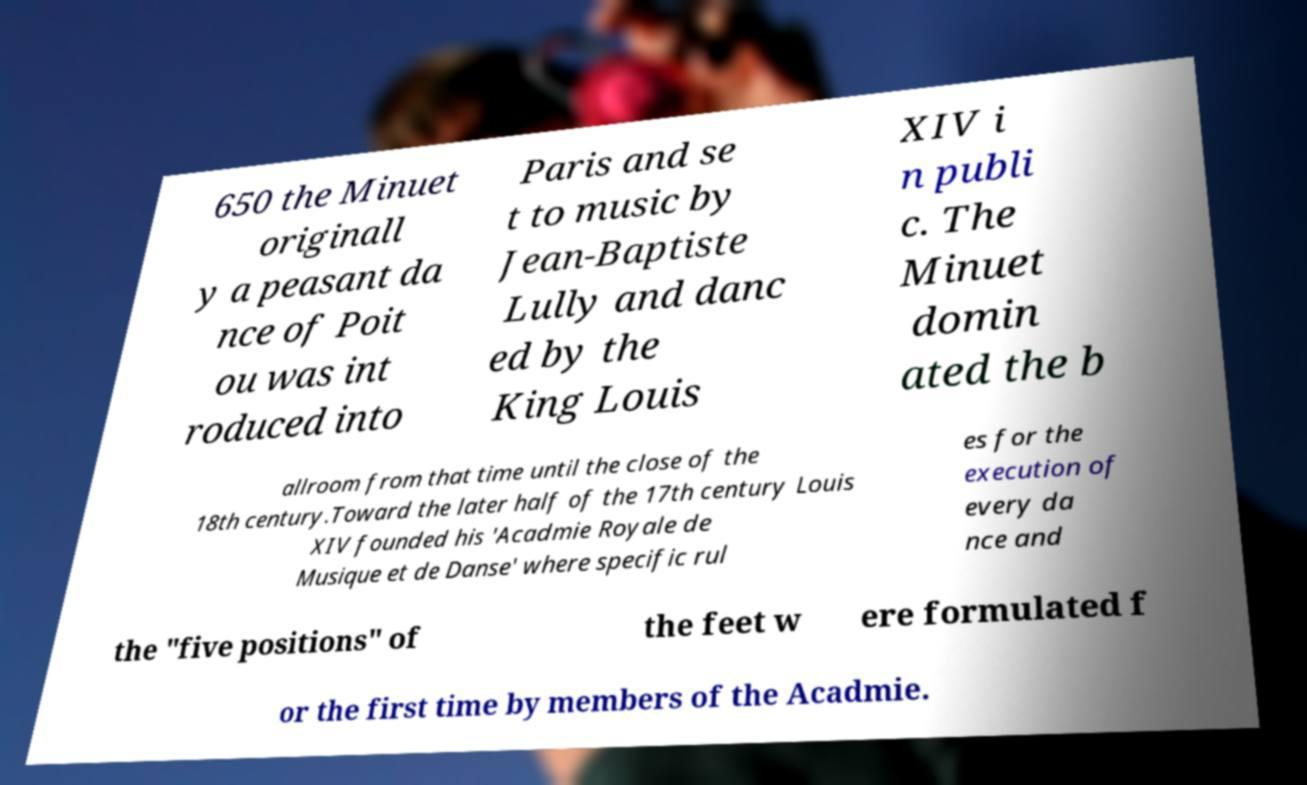Please identify and transcribe the text found in this image. 650 the Minuet originall y a peasant da nce of Poit ou was int roduced into Paris and se t to music by Jean-Baptiste Lully and danc ed by the King Louis XIV i n publi c. The Minuet domin ated the b allroom from that time until the close of the 18th century.Toward the later half of the 17th century Louis XIV founded his 'Acadmie Royale de Musique et de Danse' where specific rul es for the execution of every da nce and the "five positions" of the feet w ere formulated f or the first time by members of the Acadmie. 